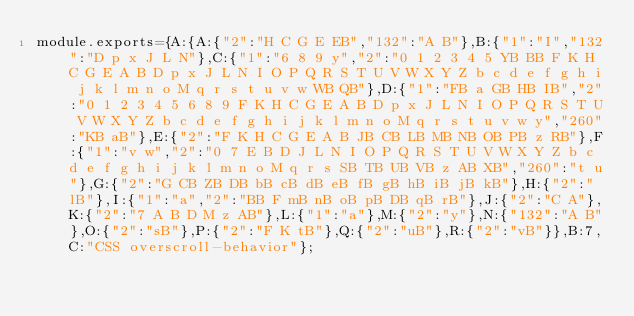Convert code to text. <code><loc_0><loc_0><loc_500><loc_500><_JavaScript_>module.exports={A:{A:{"2":"H C G E EB","132":"A B"},B:{"1":"I","132":"D p x J L N"},C:{"1":"6 8 9 y","2":"0 1 2 3 4 5 YB BB F K H C G E A B D p x J L N I O P Q R S T U V W X Y Z b c d e f g h i j k l m n o M q r s t u v w WB QB"},D:{"1":"FB a GB HB IB","2":"0 1 2 3 4 5 6 8 9 F K H C G E A B D p x J L N I O P Q R S T U V W X Y Z b c d e f g h i j k l m n o M q r s t u v w y","260":"KB aB"},E:{"2":"F K H C G E A B JB CB LB MB NB OB PB z RB"},F:{"1":"v w","2":"0 7 E B D J L N I O P Q R S T U V W X Y Z b c d e f g h i j k l m n o M q r s SB TB UB VB z AB XB","260":"t u"},G:{"2":"G CB ZB DB bB cB dB eB fB gB hB iB jB kB"},H:{"2":"lB"},I:{"1":"a","2":"BB F mB nB oB pB DB qB rB"},J:{"2":"C A"},K:{"2":"7 A B D M z AB"},L:{"1":"a"},M:{"2":"y"},N:{"132":"A B"},O:{"2":"sB"},P:{"2":"F K tB"},Q:{"2":"uB"},R:{"2":"vB"}},B:7,C:"CSS overscroll-behavior"};
</code> 